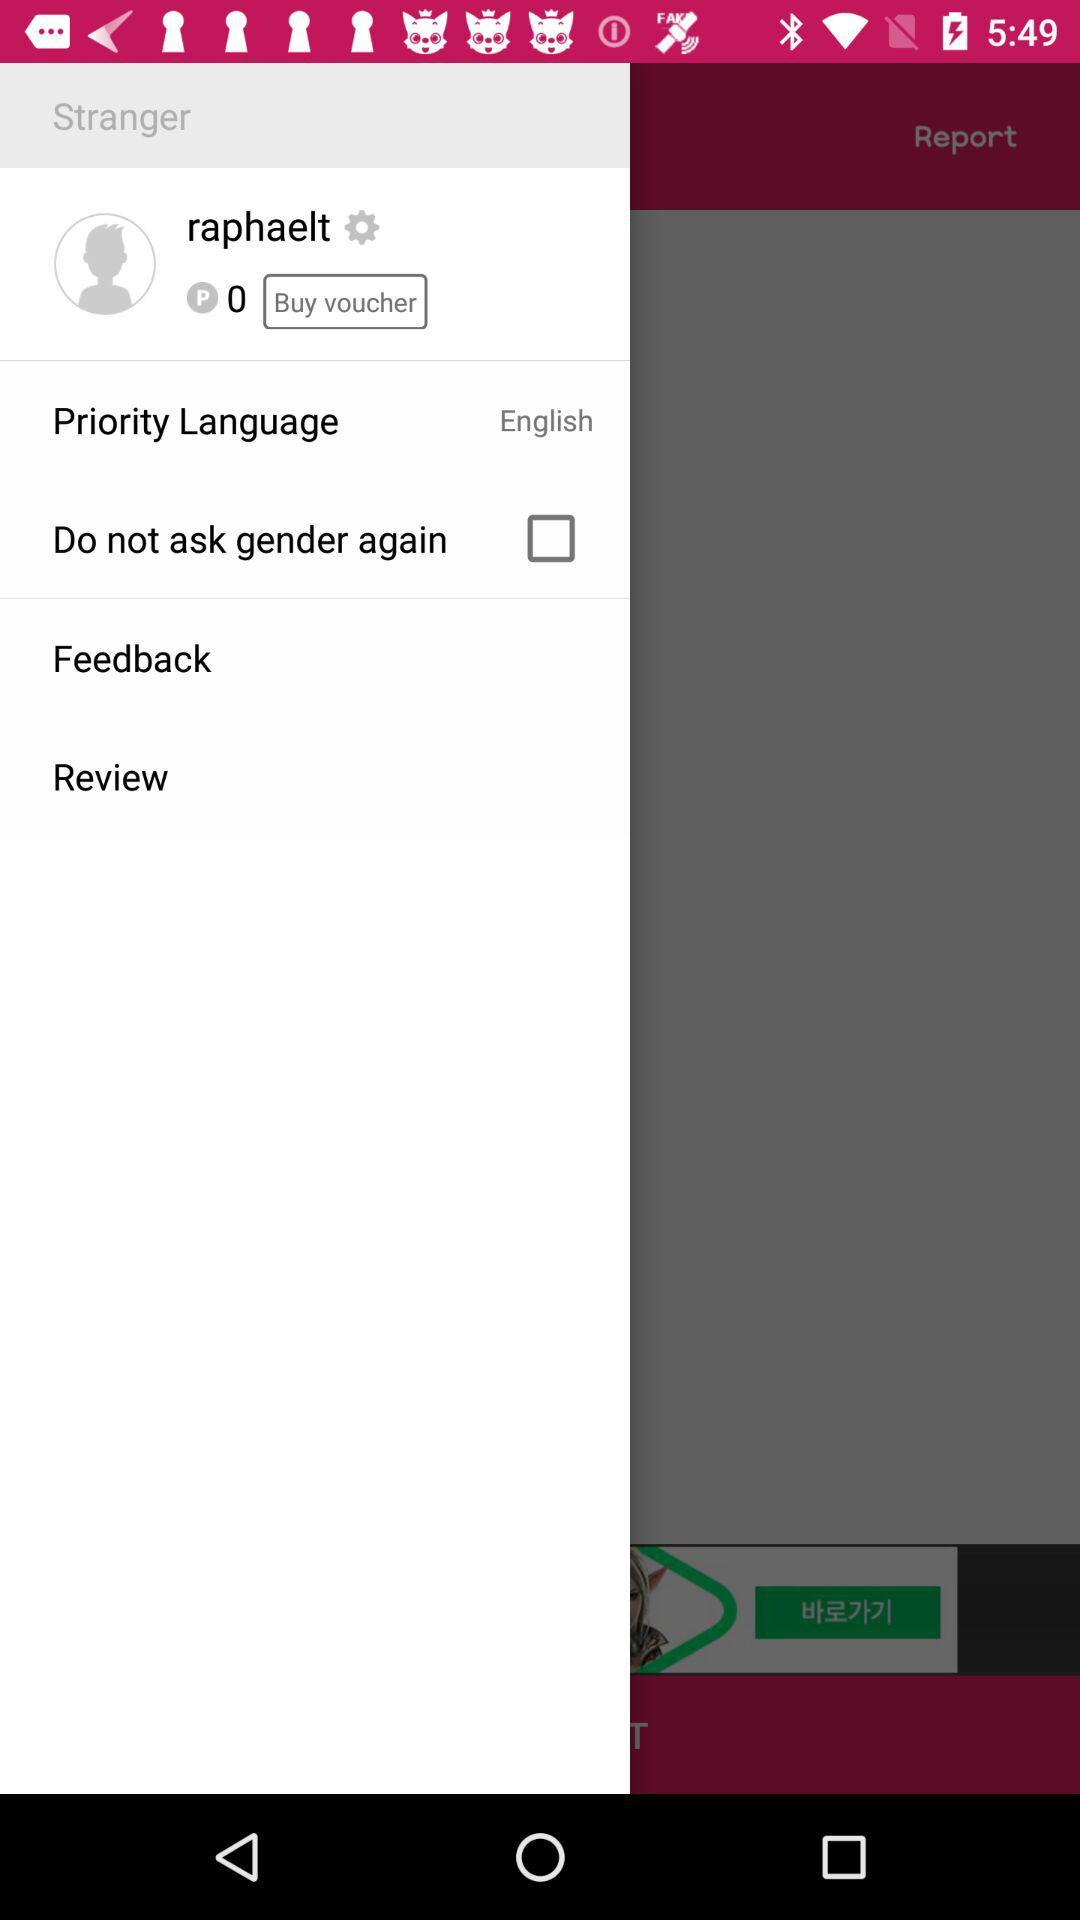What is the status of "Do not ask gender again"? The status is "off". 